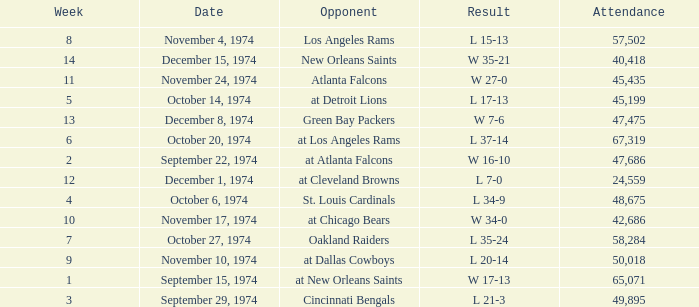Parse the full table. {'header': ['Week', 'Date', 'Opponent', 'Result', 'Attendance'], 'rows': [['8', 'November 4, 1974', 'Los Angeles Rams', 'L 15-13', '57,502'], ['14', 'December 15, 1974', 'New Orleans Saints', 'W 35-21', '40,418'], ['11', 'November 24, 1974', 'Atlanta Falcons', 'W 27-0', '45,435'], ['5', 'October 14, 1974', 'at Detroit Lions', 'L 17-13', '45,199'], ['13', 'December 8, 1974', 'Green Bay Packers', 'W 7-6', '47,475'], ['6', 'October 20, 1974', 'at Los Angeles Rams', 'L 37-14', '67,319'], ['2', 'September 22, 1974', 'at Atlanta Falcons', 'W 16-10', '47,686'], ['12', 'December 1, 1974', 'at Cleveland Browns', 'L 7-0', '24,559'], ['4', 'October 6, 1974', 'St. Louis Cardinals', 'L 34-9', '48,675'], ['10', 'November 17, 1974', 'at Chicago Bears', 'W 34-0', '42,686'], ['7', 'October 27, 1974', 'Oakland Raiders', 'L 35-24', '58,284'], ['9', 'November 10, 1974', 'at Dallas Cowboys', 'L 20-14', '50,018'], ['1', 'September 15, 1974', 'at New Orleans Saints', 'W 17-13', '65,071'], ['3', 'September 29, 1974', 'Cincinnati Bengals', 'L 21-3', '49,895']]} What was the attendance when they played at Detroit Lions? 45199.0. 